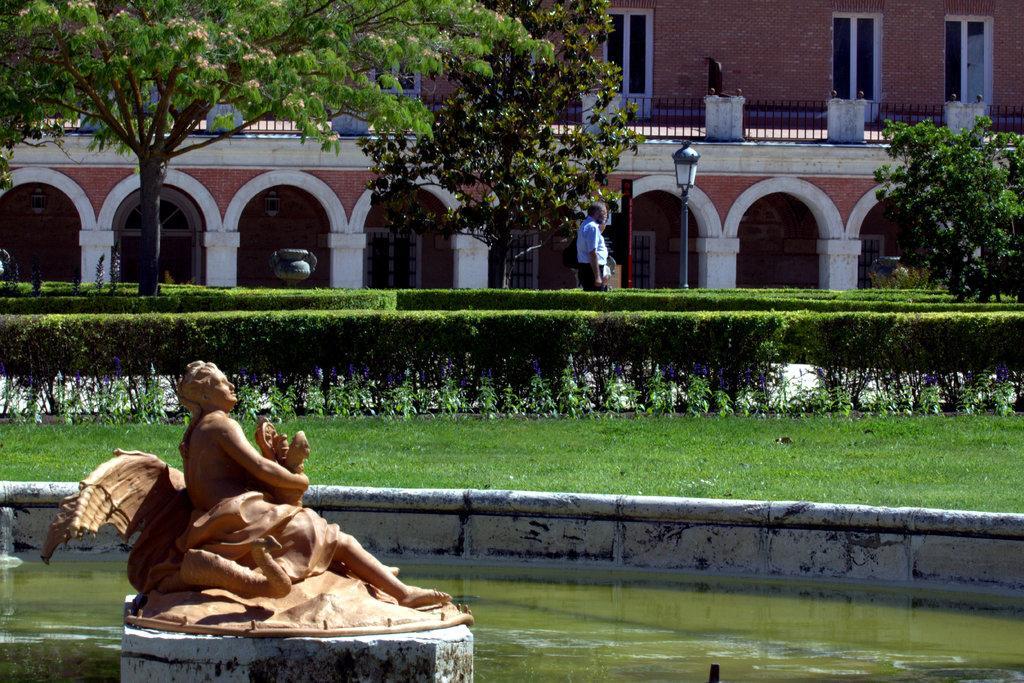Can you describe this image briefly? On the left side of the image we can see a statue. In the background of the image we can see a building, windows, pillars, trees, electric light poles, bushes, grass. In the center of the image we can see a man is standing. At the bottom of the image we can see a pool which consists of water. 